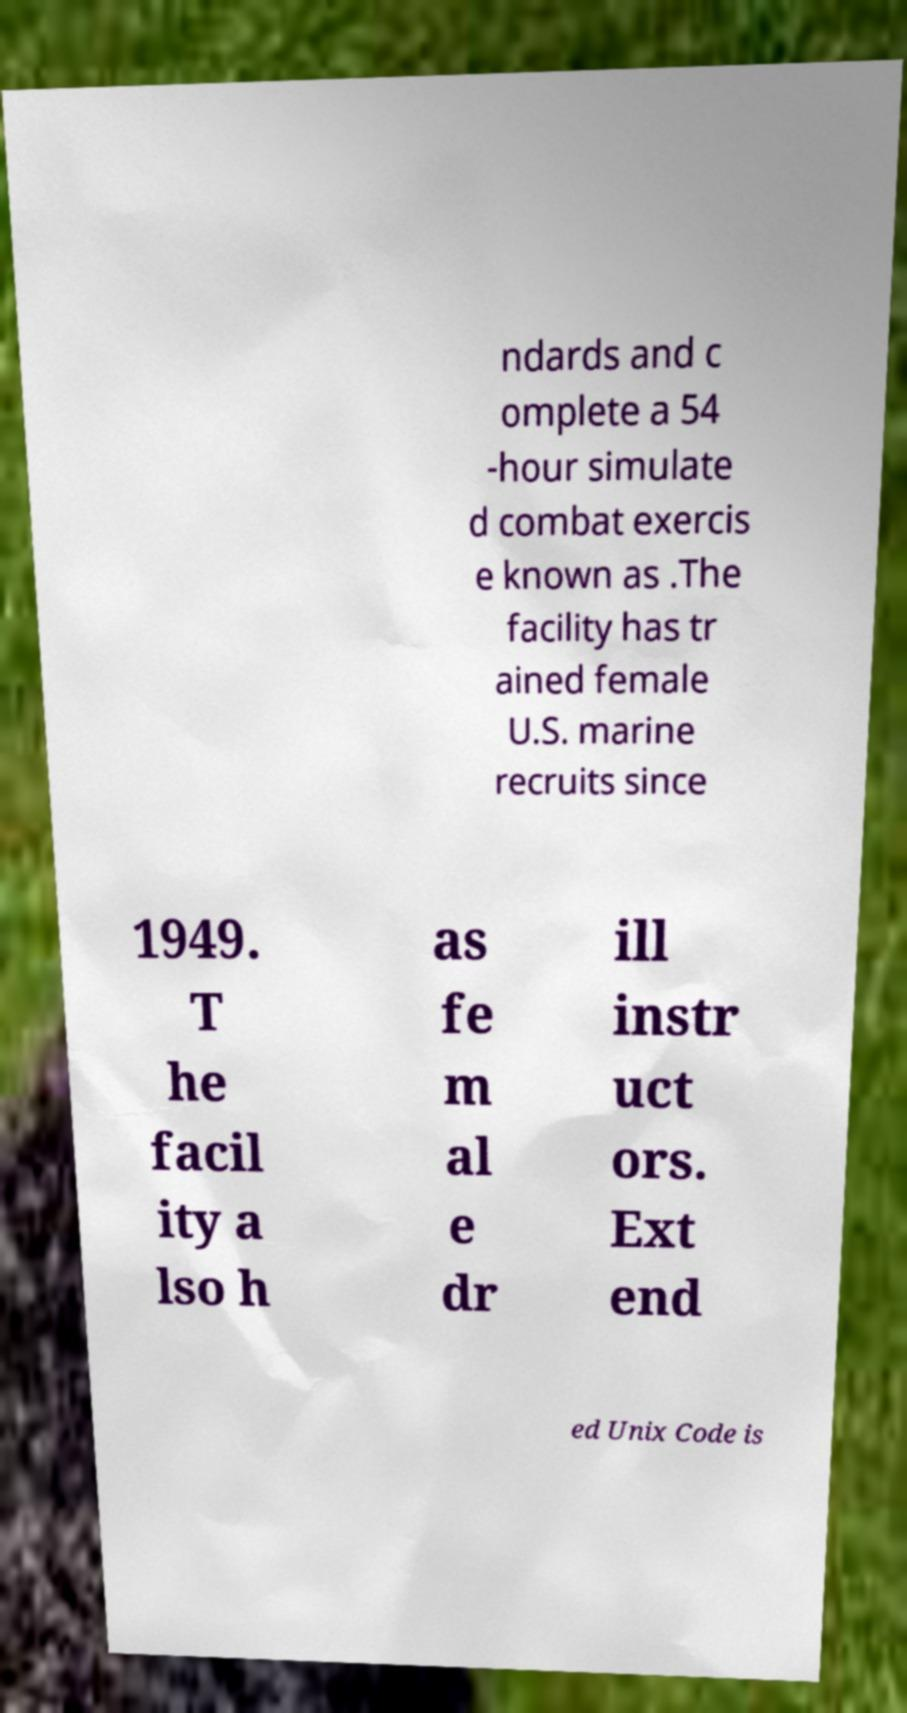What messages or text are displayed in this image? I need them in a readable, typed format. ndards and c omplete a 54 -hour simulate d combat exercis e known as .The facility has tr ained female U.S. marine recruits since 1949. T he facil ity a lso h as fe m al e dr ill instr uct ors. Ext end ed Unix Code is 